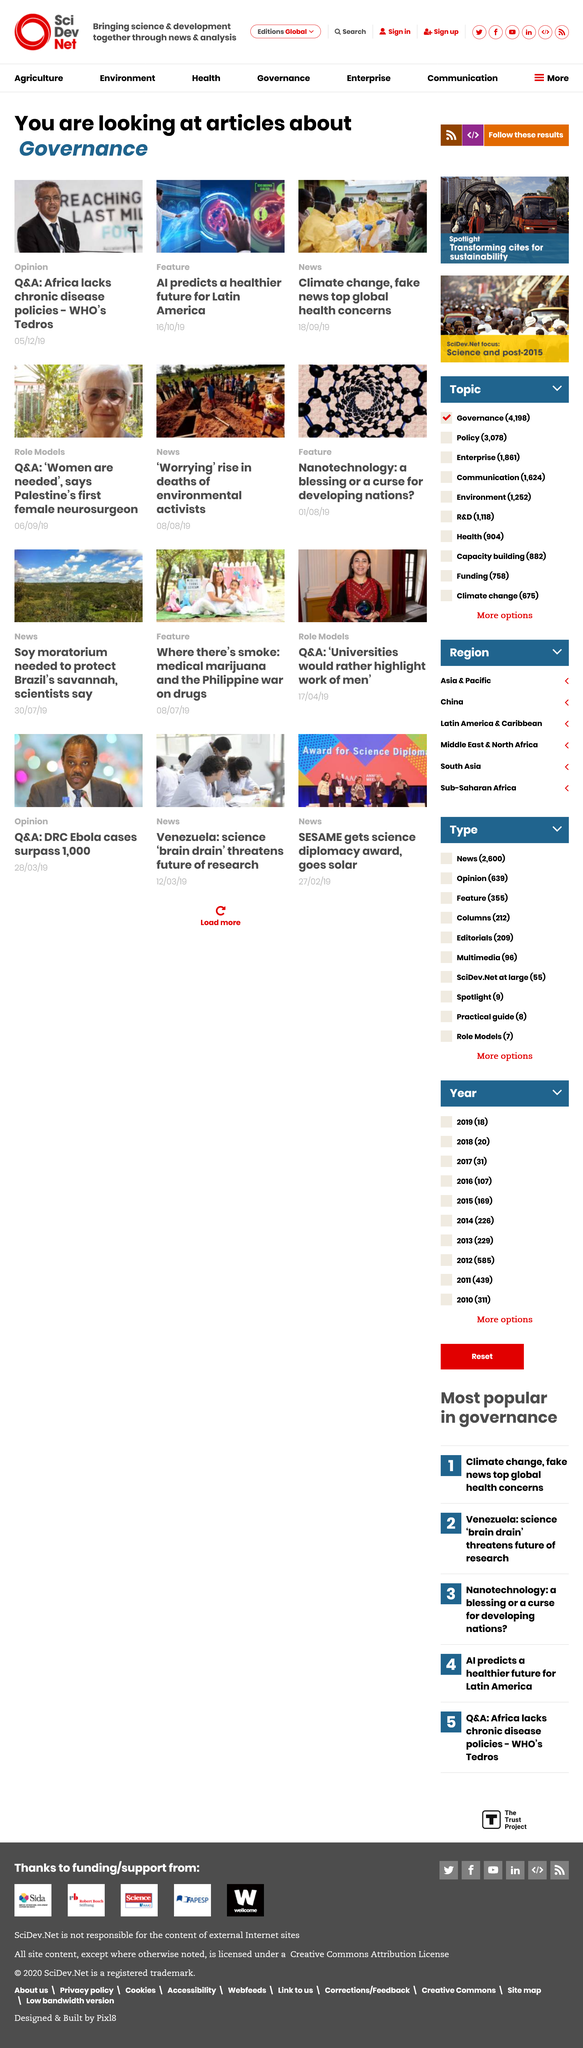Identify some key points in this picture. The article "AI prediction: Boris Johnson will win by a landslide" was published on October 16th, 2019. The general topic of the articles is governance. The "Climate Change, .." article is from September 18, 2019. 